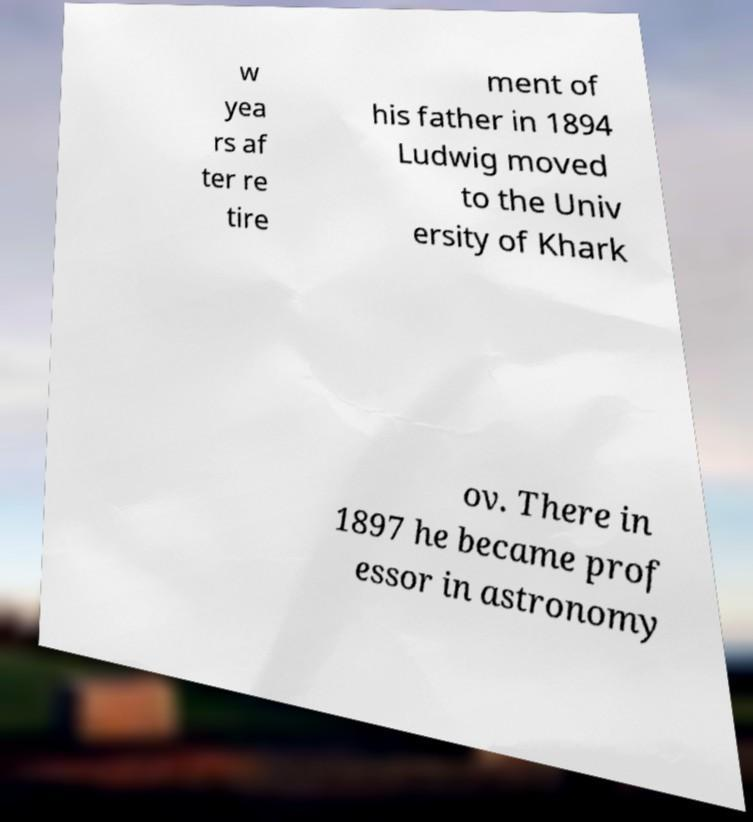I need the written content from this picture converted into text. Can you do that? w yea rs af ter re tire ment of his father in 1894 Ludwig moved to the Univ ersity of Khark ov. There in 1897 he became prof essor in astronomy 